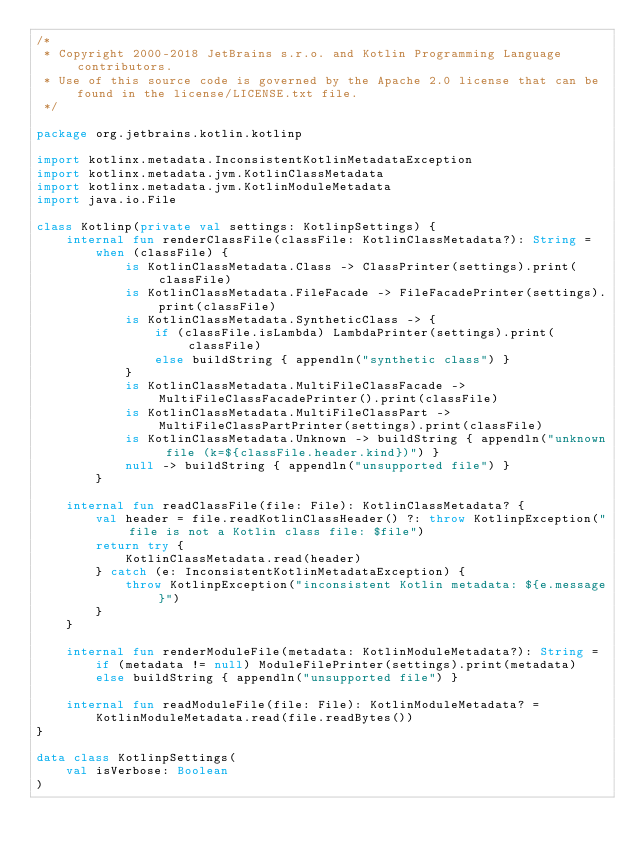Convert code to text. <code><loc_0><loc_0><loc_500><loc_500><_Kotlin_>/*
 * Copyright 2000-2018 JetBrains s.r.o. and Kotlin Programming Language contributors.
 * Use of this source code is governed by the Apache 2.0 license that can be found in the license/LICENSE.txt file.
 */

package org.jetbrains.kotlin.kotlinp

import kotlinx.metadata.InconsistentKotlinMetadataException
import kotlinx.metadata.jvm.KotlinClassMetadata
import kotlinx.metadata.jvm.KotlinModuleMetadata
import java.io.File

class Kotlinp(private val settings: KotlinpSettings) {
    internal fun renderClassFile(classFile: KotlinClassMetadata?): String =
        when (classFile) {
            is KotlinClassMetadata.Class -> ClassPrinter(settings).print(classFile)
            is KotlinClassMetadata.FileFacade -> FileFacadePrinter(settings).print(classFile)
            is KotlinClassMetadata.SyntheticClass -> {
                if (classFile.isLambda) LambdaPrinter(settings).print(classFile)
                else buildString { appendln("synthetic class") }
            }
            is KotlinClassMetadata.MultiFileClassFacade -> MultiFileClassFacadePrinter().print(classFile)
            is KotlinClassMetadata.MultiFileClassPart -> MultiFileClassPartPrinter(settings).print(classFile)
            is KotlinClassMetadata.Unknown -> buildString { appendln("unknown file (k=${classFile.header.kind})") }
            null -> buildString { appendln("unsupported file") }
        }

    internal fun readClassFile(file: File): KotlinClassMetadata? {
        val header = file.readKotlinClassHeader() ?: throw KotlinpException("file is not a Kotlin class file: $file")
        return try {
            KotlinClassMetadata.read(header)
        } catch (e: InconsistentKotlinMetadataException) {
            throw KotlinpException("inconsistent Kotlin metadata: ${e.message}")
        }
    }

    internal fun renderModuleFile(metadata: KotlinModuleMetadata?): String =
        if (metadata != null) ModuleFilePrinter(settings).print(metadata)
        else buildString { appendln("unsupported file") }

    internal fun readModuleFile(file: File): KotlinModuleMetadata? =
        KotlinModuleMetadata.read(file.readBytes())
}

data class KotlinpSettings(
    val isVerbose: Boolean
)
</code> 